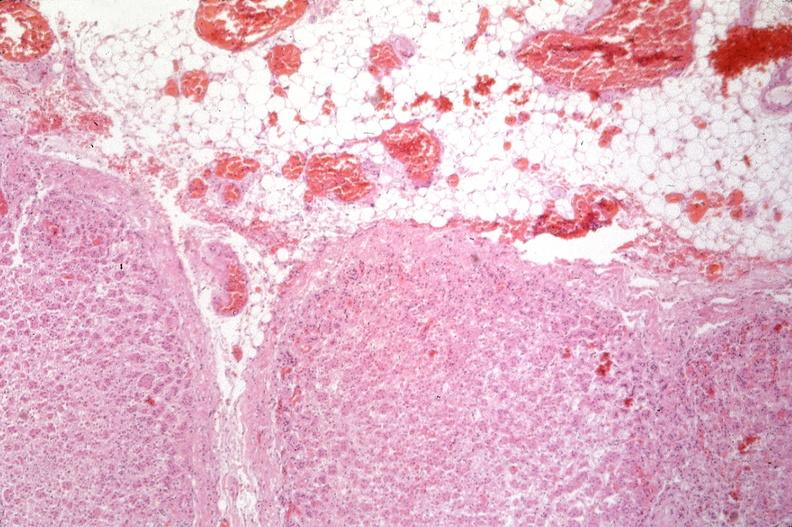what does this image show?
Answer the question using a single word or phrase. Pancreas 